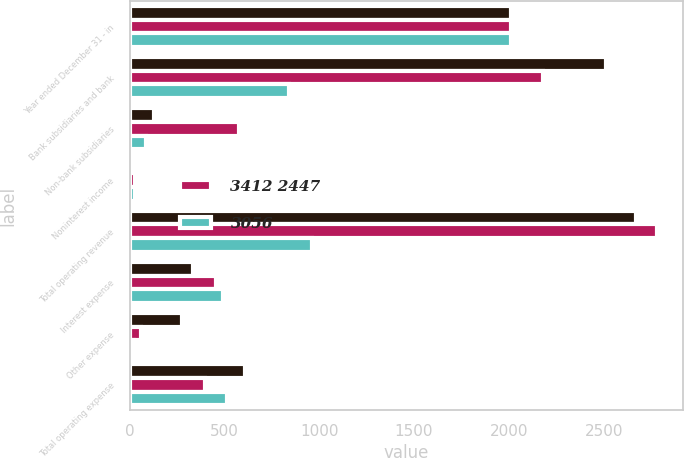Convert chart. <chart><loc_0><loc_0><loc_500><loc_500><stacked_bar_chart><ecel><fcel>Year ended December 31 - in<fcel>Bank subsidiaries and bank<fcel>Non-bank subsidiaries<fcel>Noninterest income<fcel>Total operating revenue<fcel>Interest expense<fcel>Other expense<fcel>Total operating expense<nl><fcel>nan<fcel>2011<fcel>2513<fcel>131<fcel>24<fcel>2669<fcel>333<fcel>275<fcel>608<nl><fcel>3412 2447<fcel>2010<fcel>2180<fcel>575<fcel>27<fcel>2782<fcel>458<fcel>61<fcel>397<nl><fcel>3056<fcel>2009<fcel>839<fcel>84<fcel>28<fcel>963<fcel>495<fcel>21<fcel>516<nl></chart> 